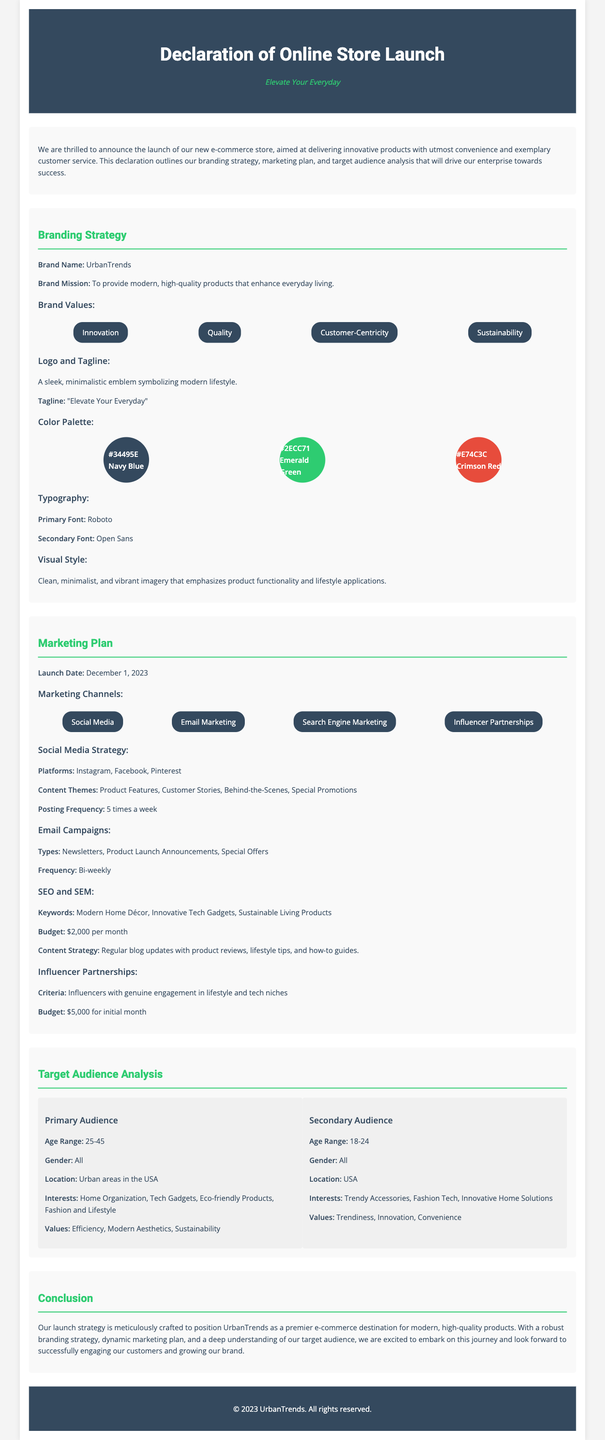What is the brand name? The brand name is explicitly stated in the branding strategy section.
Answer: UrbanTrends What is the launch date of the online store? The launch date is mentioned in the marketing plan section.
Answer: December 1, 2023 What are the three marketing channels listed? The marketing channels are listed in the marketing plan section, and three examples can be selected from there.
Answer: Social Media, Email Marketing, Search Engine Marketing What is the primary audience's age range? The age range of the primary audience is given in the target audience analysis section.
Answer: 25-45 What is the budget allocated for SEO and SEM per month? The budget is specified in the marketing plan under SEO and SEM.
Answer: $2,000 per month What is UrbanTrends' brand mission? The brand mission is outlined in the branding strategy section.
Answer: To provide modern, high-quality products that enhance everyday living What color represents "Emerald Green" in the color palette? The color is specified in the branding strategy's color palette section.
Answer: #2ECC71 What type of content themes will be posted on social media? Content themes are listed in the social media strategy under the marketing plan.
Answer: Product Features, Customer Stories, Behind-the-Scenes, Special Promotions What is the budget for influencer partnerships in the first month? The budget for influencer partnerships is detailed in the marketing plan section.
Answer: $5,000 for initial month 